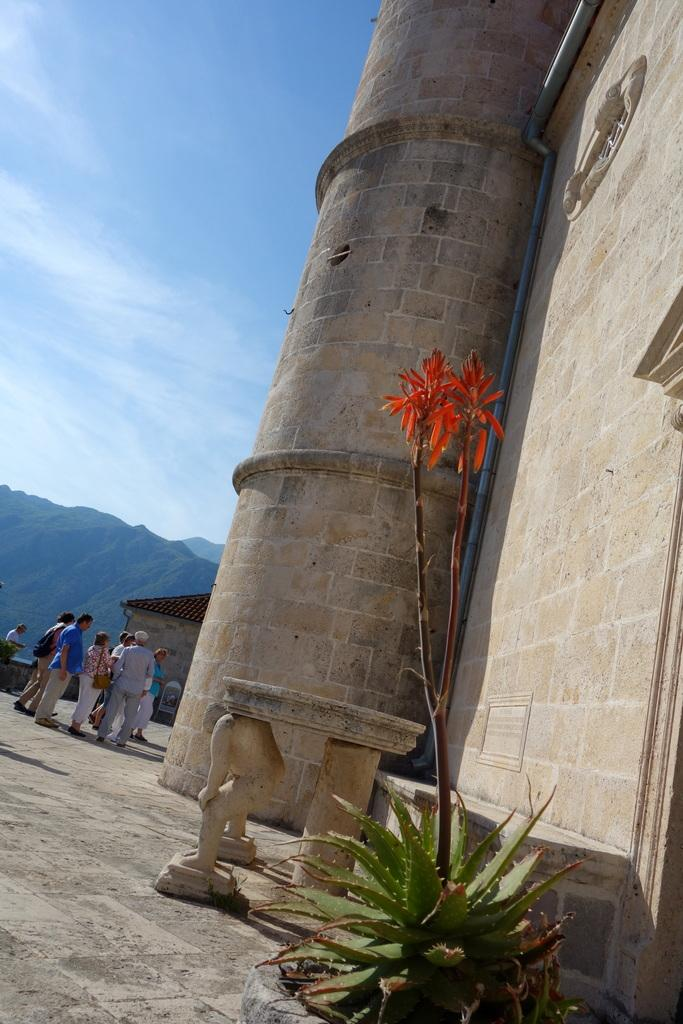What type of structure is present in the image? There is a building in the image. Who or what else can be seen in the image? There are people in the image. Can you describe the plant in the image? The plant has green and orange colors in the image. What can be seen in the distance in the image? There are mountains visible in the background of the image. How would you describe the sky in the image? The sky is a combination of white and blue colors. What is the end of the quiver used for in the image? There is no quiver present in the image, so this question cannot be answered. What is the plot of the story being told in the image? There is no story being told in the image, so this question cannot be answered. 